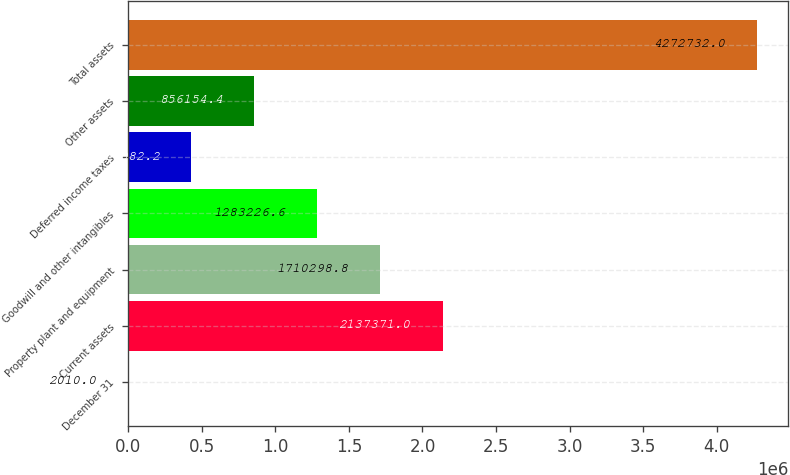Convert chart. <chart><loc_0><loc_0><loc_500><loc_500><bar_chart><fcel>December 31<fcel>Current assets<fcel>Property plant and equipment<fcel>Goodwill and other intangibles<fcel>Deferred income taxes<fcel>Other assets<fcel>Total assets<nl><fcel>2010<fcel>2.13737e+06<fcel>1.7103e+06<fcel>1.28323e+06<fcel>429082<fcel>856154<fcel>4.27273e+06<nl></chart> 